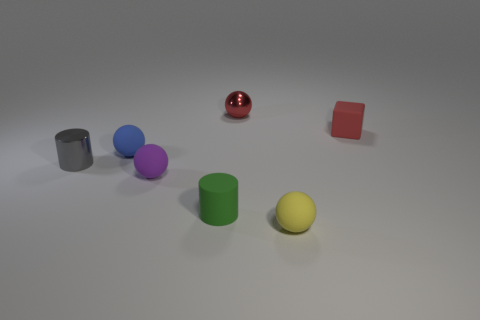Add 2 tiny blue rubber cylinders. How many objects exist? 9 Subtract all spheres. How many objects are left? 3 Add 4 tiny brown matte objects. How many tiny brown matte objects exist? 4 Subtract 0 yellow cylinders. How many objects are left? 7 Subtract all tiny brown rubber cylinders. Subtract all red shiny balls. How many objects are left? 6 Add 1 small green cylinders. How many small green cylinders are left? 2 